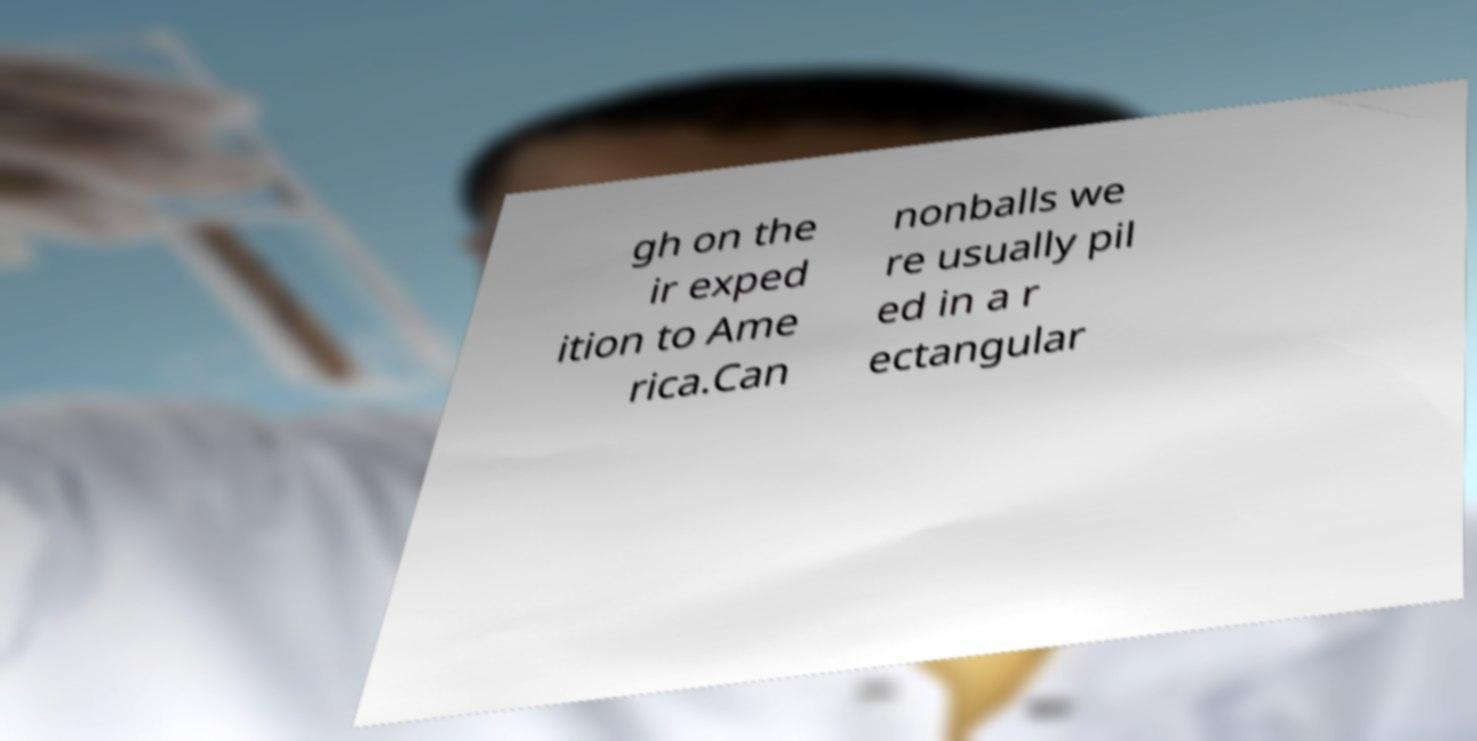Please read and relay the text visible in this image. What does it say? gh on the ir exped ition to Ame rica.Can nonballs we re usually pil ed in a r ectangular 